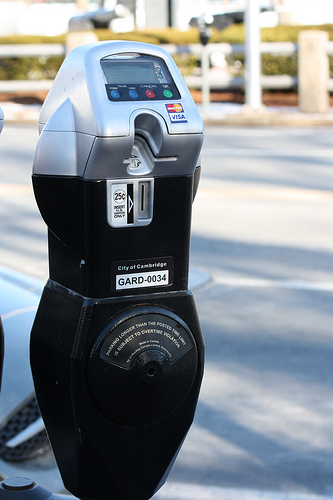Please provide the bounding box coordinate of the region this sentence describes: Credit card slot on parking meter. The bounding box coordinates for the credit card slot on the parking meter are approximately [0.39, 0.2, 0.55, 0.35]. This area outlines the slot where credit cards are inserted, a critical component for facilitating electronic payment. 